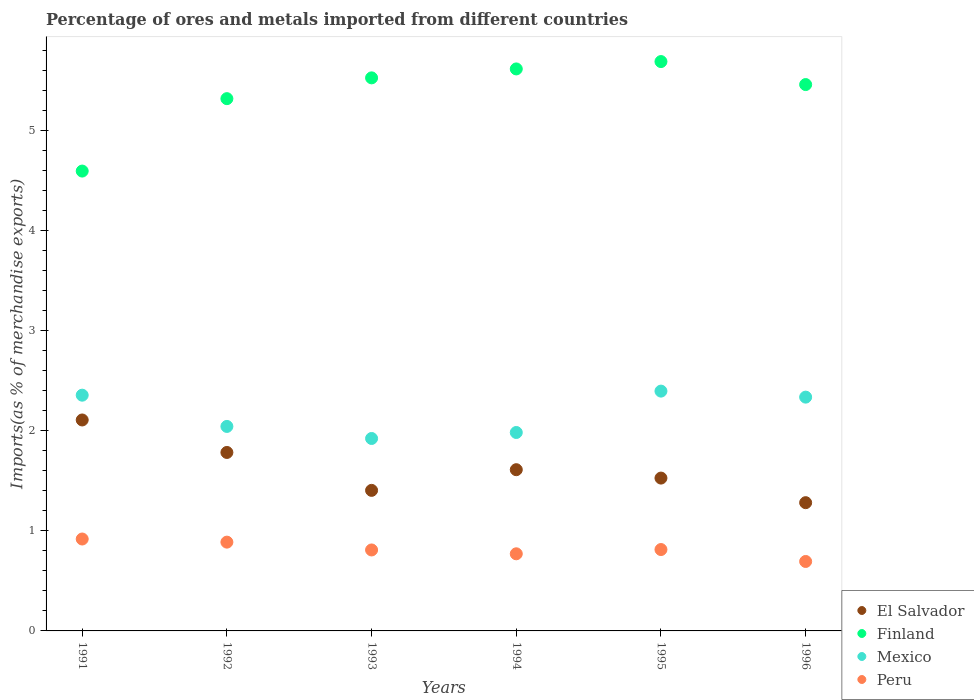How many different coloured dotlines are there?
Offer a terse response. 4. Is the number of dotlines equal to the number of legend labels?
Offer a terse response. Yes. What is the percentage of imports to different countries in Finland in 1991?
Your response must be concise. 4.59. Across all years, what is the maximum percentage of imports to different countries in El Salvador?
Offer a very short reply. 2.11. Across all years, what is the minimum percentage of imports to different countries in Finland?
Provide a succinct answer. 4.59. In which year was the percentage of imports to different countries in El Salvador maximum?
Provide a short and direct response. 1991. In which year was the percentage of imports to different countries in Finland minimum?
Offer a terse response. 1991. What is the total percentage of imports to different countries in Peru in the graph?
Offer a very short reply. 4.89. What is the difference between the percentage of imports to different countries in Mexico in 1992 and that in 1994?
Make the answer very short. 0.06. What is the difference between the percentage of imports to different countries in Peru in 1992 and the percentage of imports to different countries in Mexico in 1996?
Give a very brief answer. -1.45. What is the average percentage of imports to different countries in Mexico per year?
Ensure brevity in your answer.  2.17. In the year 1996, what is the difference between the percentage of imports to different countries in Mexico and percentage of imports to different countries in Peru?
Make the answer very short. 1.64. What is the ratio of the percentage of imports to different countries in Peru in 1993 to that in 1996?
Offer a terse response. 1.17. Is the percentage of imports to different countries in El Salvador in 1993 less than that in 1994?
Provide a succinct answer. Yes. What is the difference between the highest and the second highest percentage of imports to different countries in Mexico?
Make the answer very short. 0.04. What is the difference between the highest and the lowest percentage of imports to different countries in Mexico?
Ensure brevity in your answer.  0.47. Is the sum of the percentage of imports to different countries in El Salvador in 1993 and 1995 greater than the maximum percentage of imports to different countries in Mexico across all years?
Keep it short and to the point. Yes. Is it the case that in every year, the sum of the percentage of imports to different countries in Finland and percentage of imports to different countries in Mexico  is greater than the sum of percentage of imports to different countries in El Salvador and percentage of imports to different countries in Peru?
Give a very brief answer. Yes. Is it the case that in every year, the sum of the percentage of imports to different countries in Finland and percentage of imports to different countries in El Salvador  is greater than the percentage of imports to different countries in Peru?
Provide a succinct answer. Yes. Is the percentage of imports to different countries in Mexico strictly greater than the percentage of imports to different countries in Finland over the years?
Offer a very short reply. No. Is the percentage of imports to different countries in El Salvador strictly less than the percentage of imports to different countries in Peru over the years?
Your answer should be compact. No. How many years are there in the graph?
Provide a succinct answer. 6. Are the values on the major ticks of Y-axis written in scientific E-notation?
Provide a short and direct response. No. Does the graph contain grids?
Provide a succinct answer. No. Where does the legend appear in the graph?
Provide a succinct answer. Bottom right. What is the title of the graph?
Provide a succinct answer. Percentage of ores and metals imported from different countries. Does "Ukraine" appear as one of the legend labels in the graph?
Provide a succinct answer. No. What is the label or title of the Y-axis?
Ensure brevity in your answer.  Imports(as % of merchandise exports). What is the Imports(as % of merchandise exports) of El Salvador in 1991?
Provide a succinct answer. 2.11. What is the Imports(as % of merchandise exports) in Finland in 1991?
Offer a very short reply. 4.59. What is the Imports(as % of merchandise exports) in Mexico in 1991?
Your answer should be compact. 2.36. What is the Imports(as % of merchandise exports) of Peru in 1991?
Give a very brief answer. 0.92. What is the Imports(as % of merchandise exports) of El Salvador in 1992?
Give a very brief answer. 1.78. What is the Imports(as % of merchandise exports) of Finland in 1992?
Keep it short and to the point. 5.32. What is the Imports(as % of merchandise exports) in Mexico in 1992?
Your answer should be very brief. 2.04. What is the Imports(as % of merchandise exports) in Peru in 1992?
Your response must be concise. 0.89. What is the Imports(as % of merchandise exports) in El Salvador in 1993?
Provide a succinct answer. 1.4. What is the Imports(as % of merchandise exports) of Finland in 1993?
Make the answer very short. 5.53. What is the Imports(as % of merchandise exports) of Mexico in 1993?
Your response must be concise. 1.92. What is the Imports(as % of merchandise exports) in Peru in 1993?
Provide a succinct answer. 0.81. What is the Imports(as % of merchandise exports) of El Salvador in 1994?
Ensure brevity in your answer.  1.61. What is the Imports(as % of merchandise exports) in Finland in 1994?
Ensure brevity in your answer.  5.61. What is the Imports(as % of merchandise exports) in Mexico in 1994?
Ensure brevity in your answer.  1.98. What is the Imports(as % of merchandise exports) in Peru in 1994?
Your answer should be very brief. 0.77. What is the Imports(as % of merchandise exports) in El Salvador in 1995?
Your answer should be very brief. 1.53. What is the Imports(as % of merchandise exports) in Finland in 1995?
Offer a very short reply. 5.69. What is the Imports(as % of merchandise exports) of Mexico in 1995?
Provide a short and direct response. 2.4. What is the Imports(as % of merchandise exports) in Peru in 1995?
Ensure brevity in your answer.  0.81. What is the Imports(as % of merchandise exports) in El Salvador in 1996?
Make the answer very short. 1.28. What is the Imports(as % of merchandise exports) of Finland in 1996?
Your answer should be compact. 5.46. What is the Imports(as % of merchandise exports) of Mexico in 1996?
Keep it short and to the point. 2.34. What is the Imports(as % of merchandise exports) of Peru in 1996?
Provide a short and direct response. 0.69. Across all years, what is the maximum Imports(as % of merchandise exports) in El Salvador?
Your answer should be very brief. 2.11. Across all years, what is the maximum Imports(as % of merchandise exports) of Finland?
Provide a short and direct response. 5.69. Across all years, what is the maximum Imports(as % of merchandise exports) of Mexico?
Offer a terse response. 2.4. Across all years, what is the maximum Imports(as % of merchandise exports) of Peru?
Offer a terse response. 0.92. Across all years, what is the minimum Imports(as % of merchandise exports) of El Salvador?
Your answer should be compact. 1.28. Across all years, what is the minimum Imports(as % of merchandise exports) of Finland?
Provide a succinct answer. 4.59. Across all years, what is the minimum Imports(as % of merchandise exports) in Mexico?
Your answer should be compact. 1.92. Across all years, what is the minimum Imports(as % of merchandise exports) of Peru?
Offer a terse response. 0.69. What is the total Imports(as % of merchandise exports) of El Salvador in the graph?
Make the answer very short. 9.71. What is the total Imports(as % of merchandise exports) of Finland in the graph?
Offer a very short reply. 32.2. What is the total Imports(as % of merchandise exports) of Mexico in the graph?
Offer a very short reply. 13.03. What is the total Imports(as % of merchandise exports) in Peru in the graph?
Provide a succinct answer. 4.89. What is the difference between the Imports(as % of merchandise exports) of El Salvador in 1991 and that in 1992?
Offer a terse response. 0.32. What is the difference between the Imports(as % of merchandise exports) in Finland in 1991 and that in 1992?
Keep it short and to the point. -0.72. What is the difference between the Imports(as % of merchandise exports) of Mexico in 1991 and that in 1992?
Offer a terse response. 0.31. What is the difference between the Imports(as % of merchandise exports) of Peru in 1991 and that in 1992?
Provide a short and direct response. 0.03. What is the difference between the Imports(as % of merchandise exports) of El Salvador in 1991 and that in 1993?
Offer a very short reply. 0.7. What is the difference between the Imports(as % of merchandise exports) of Finland in 1991 and that in 1993?
Offer a very short reply. -0.93. What is the difference between the Imports(as % of merchandise exports) in Mexico in 1991 and that in 1993?
Give a very brief answer. 0.43. What is the difference between the Imports(as % of merchandise exports) of Peru in 1991 and that in 1993?
Make the answer very short. 0.11. What is the difference between the Imports(as % of merchandise exports) of El Salvador in 1991 and that in 1994?
Your response must be concise. 0.5. What is the difference between the Imports(as % of merchandise exports) of Finland in 1991 and that in 1994?
Give a very brief answer. -1.02. What is the difference between the Imports(as % of merchandise exports) of Mexico in 1991 and that in 1994?
Ensure brevity in your answer.  0.37. What is the difference between the Imports(as % of merchandise exports) of Peru in 1991 and that in 1994?
Offer a very short reply. 0.15. What is the difference between the Imports(as % of merchandise exports) in El Salvador in 1991 and that in 1995?
Your answer should be very brief. 0.58. What is the difference between the Imports(as % of merchandise exports) of Finland in 1991 and that in 1995?
Your answer should be compact. -1.09. What is the difference between the Imports(as % of merchandise exports) in Mexico in 1991 and that in 1995?
Provide a succinct answer. -0.04. What is the difference between the Imports(as % of merchandise exports) in Peru in 1991 and that in 1995?
Give a very brief answer. 0.11. What is the difference between the Imports(as % of merchandise exports) of El Salvador in 1991 and that in 1996?
Make the answer very short. 0.83. What is the difference between the Imports(as % of merchandise exports) of Finland in 1991 and that in 1996?
Provide a short and direct response. -0.86. What is the difference between the Imports(as % of merchandise exports) of Mexico in 1991 and that in 1996?
Your answer should be compact. 0.02. What is the difference between the Imports(as % of merchandise exports) in Peru in 1991 and that in 1996?
Provide a short and direct response. 0.22. What is the difference between the Imports(as % of merchandise exports) in El Salvador in 1992 and that in 1993?
Make the answer very short. 0.38. What is the difference between the Imports(as % of merchandise exports) of Finland in 1992 and that in 1993?
Your answer should be compact. -0.21. What is the difference between the Imports(as % of merchandise exports) in Mexico in 1992 and that in 1993?
Your answer should be very brief. 0.12. What is the difference between the Imports(as % of merchandise exports) of Peru in 1992 and that in 1993?
Provide a succinct answer. 0.08. What is the difference between the Imports(as % of merchandise exports) in El Salvador in 1992 and that in 1994?
Offer a very short reply. 0.17. What is the difference between the Imports(as % of merchandise exports) in Finland in 1992 and that in 1994?
Ensure brevity in your answer.  -0.3. What is the difference between the Imports(as % of merchandise exports) in Mexico in 1992 and that in 1994?
Your answer should be very brief. 0.06. What is the difference between the Imports(as % of merchandise exports) of Peru in 1992 and that in 1994?
Provide a succinct answer. 0.12. What is the difference between the Imports(as % of merchandise exports) of El Salvador in 1992 and that in 1995?
Give a very brief answer. 0.26. What is the difference between the Imports(as % of merchandise exports) of Finland in 1992 and that in 1995?
Your answer should be very brief. -0.37. What is the difference between the Imports(as % of merchandise exports) of Mexico in 1992 and that in 1995?
Your response must be concise. -0.35. What is the difference between the Imports(as % of merchandise exports) of Peru in 1992 and that in 1995?
Provide a succinct answer. 0.07. What is the difference between the Imports(as % of merchandise exports) of El Salvador in 1992 and that in 1996?
Keep it short and to the point. 0.5. What is the difference between the Imports(as % of merchandise exports) in Finland in 1992 and that in 1996?
Your response must be concise. -0.14. What is the difference between the Imports(as % of merchandise exports) in Mexico in 1992 and that in 1996?
Provide a succinct answer. -0.29. What is the difference between the Imports(as % of merchandise exports) in Peru in 1992 and that in 1996?
Keep it short and to the point. 0.19. What is the difference between the Imports(as % of merchandise exports) in El Salvador in 1993 and that in 1994?
Offer a very short reply. -0.21. What is the difference between the Imports(as % of merchandise exports) of Finland in 1993 and that in 1994?
Ensure brevity in your answer.  -0.09. What is the difference between the Imports(as % of merchandise exports) in Mexico in 1993 and that in 1994?
Your answer should be compact. -0.06. What is the difference between the Imports(as % of merchandise exports) of Peru in 1993 and that in 1994?
Provide a succinct answer. 0.04. What is the difference between the Imports(as % of merchandise exports) of El Salvador in 1993 and that in 1995?
Offer a terse response. -0.12. What is the difference between the Imports(as % of merchandise exports) of Finland in 1993 and that in 1995?
Ensure brevity in your answer.  -0.16. What is the difference between the Imports(as % of merchandise exports) in Mexico in 1993 and that in 1995?
Provide a succinct answer. -0.47. What is the difference between the Imports(as % of merchandise exports) of Peru in 1993 and that in 1995?
Your response must be concise. -0. What is the difference between the Imports(as % of merchandise exports) in El Salvador in 1993 and that in 1996?
Give a very brief answer. 0.12. What is the difference between the Imports(as % of merchandise exports) in Finland in 1993 and that in 1996?
Ensure brevity in your answer.  0.07. What is the difference between the Imports(as % of merchandise exports) of Mexico in 1993 and that in 1996?
Make the answer very short. -0.41. What is the difference between the Imports(as % of merchandise exports) in Peru in 1993 and that in 1996?
Offer a very short reply. 0.12. What is the difference between the Imports(as % of merchandise exports) in El Salvador in 1994 and that in 1995?
Make the answer very short. 0.08. What is the difference between the Imports(as % of merchandise exports) of Finland in 1994 and that in 1995?
Offer a very short reply. -0.07. What is the difference between the Imports(as % of merchandise exports) in Mexico in 1994 and that in 1995?
Offer a very short reply. -0.41. What is the difference between the Imports(as % of merchandise exports) in Peru in 1994 and that in 1995?
Offer a very short reply. -0.04. What is the difference between the Imports(as % of merchandise exports) of El Salvador in 1994 and that in 1996?
Your answer should be very brief. 0.33. What is the difference between the Imports(as % of merchandise exports) of Finland in 1994 and that in 1996?
Your response must be concise. 0.16. What is the difference between the Imports(as % of merchandise exports) of Mexico in 1994 and that in 1996?
Keep it short and to the point. -0.35. What is the difference between the Imports(as % of merchandise exports) of Peru in 1994 and that in 1996?
Provide a succinct answer. 0.08. What is the difference between the Imports(as % of merchandise exports) of El Salvador in 1995 and that in 1996?
Your response must be concise. 0.25. What is the difference between the Imports(as % of merchandise exports) in Finland in 1995 and that in 1996?
Provide a succinct answer. 0.23. What is the difference between the Imports(as % of merchandise exports) in Mexico in 1995 and that in 1996?
Provide a succinct answer. 0.06. What is the difference between the Imports(as % of merchandise exports) in Peru in 1995 and that in 1996?
Provide a short and direct response. 0.12. What is the difference between the Imports(as % of merchandise exports) in El Salvador in 1991 and the Imports(as % of merchandise exports) in Finland in 1992?
Your response must be concise. -3.21. What is the difference between the Imports(as % of merchandise exports) in El Salvador in 1991 and the Imports(as % of merchandise exports) in Mexico in 1992?
Give a very brief answer. 0.06. What is the difference between the Imports(as % of merchandise exports) in El Salvador in 1991 and the Imports(as % of merchandise exports) in Peru in 1992?
Give a very brief answer. 1.22. What is the difference between the Imports(as % of merchandise exports) in Finland in 1991 and the Imports(as % of merchandise exports) in Mexico in 1992?
Ensure brevity in your answer.  2.55. What is the difference between the Imports(as % of merchandise exports) in Finland in 1991 and the Imports(as % of merchandise exports) in Peru in 1992?
Your answer should be compact. 3.71. What is the difference between the Imports(as % of merchandise exports) of Mexico in 1991 and the Imports(as % of merchandise exports) of Peru in 1992?
Your response must be concise. 1.47. What is the difference between the Imports(as % of merchandise exports) in El Salvador in 1991 and the Imports(as % of merchandise exports) in Finland in 1993?
Ensure brevity in your answer.  -3.42. What is the difference between the Imports(as % of merchandise exports) of El Salvador in 1991 and the Imports(as % of merchandise exports) of Mexico in 1993?
Offer a terse response. 0.18. What is the difference between the Imports(as % of merchandise exports) of El Salvador in 1991 and the Imports(as % of merchandise exports) of Peru in 1993?
Provide a succinct answer. 1.3. What is the difference between the Imports(as % of merchandise exports) of Finland in 1991 and the Imports(as % of merchandise exports) of Mexico in 1993?
Make the answer very short. 2.67. What is the difference between the Imports(as % of merchandise exports) of Finland in 1991 and the Imports(as % of merchandise exports) of Peru in 1993?
Provide a short and direct response. 3.79. What is the difference between the Imports(as % of merchandise exports) of Mexico in 1991 and the Imports(as % of merchandise exports) of Peru in 1993?
Ensure brevity in your answer.  1.55. What is the difference between the Imports(as % of merchandise exports) in El Salvador in 1991 and the Imports(as % of merchandise exports) in Finland in 1994?
Your answer should be compact. -3.51. What is the difference between the Imports(as % of merchandise exports) in El Salvador in 1991 and the Imports(as % of merchandise exports) in Mexico in 1994?
Your response must be concise. 0.13. What is the difference between the Imports(as % of merchandise exports) of El Salvador in 1991 and the Imports(as % of merchandise exports) of Peru in 1994?
Your response must be concise. 1.34. What is the difference between the Imports(as % of merchandise exports) of Finland in 1991 and the Imports(as % of merchandise exports) of Mexico in 1994?
Give a very brief answer. 2.61. What is the difference between the Imports(as % of merchandise exports) of Finland in 1991 and the Imports(as % of merchandise exports) of Peru in 1994?
Provide a succinct answer. 3.82. What is the difference between the Imports(as % of merchandise exports) of Mexico in 1991 and the Imports(as % of merchandise exports) of Peru in 1994?
Provide a succinct answer. 1.58. What is the difference between the Imports(as % of merchandise exports) of El Salvador in 1991 and the Imports(as % of merchandise exports) of Finland in 1995?
Offer a very short reply. -3.58. What is the difference between the Imports(as % of merchandise exports) in El Salvador in 1991 and the Imports(as % of merchandise exports) in Mexico in 1995?
Offer a terse response. -0.29. What is the difference between the Imports(as % of merchandise exports) in El Salvador in 1991 and the Imports(as % of merchandise exports) in Peru in 1995?
Give a very brief answer. 1.29. What is the difference between the Imports(as % of merchandise exports) in Finland in 1991 and the Imports(as % of merchandise exports) in Mexico in 1995?
Provide a short and direct response. 2.2. What is the difference between the Imports(as % of merchandise exports) in Finland in 1991 and the Imports(as % of merchandise exports) in Peru in 1995?
Offer a terse response. 3.78. What is the difference between the Imports(as % of merchandise exports) in Mexico in 1991 and the Imports(as % of merchandise exports) in Peru in 1995?
Offer a terse response. 1.54. What is the difference between the Imports(as % of merchandise exports) of El Salvador in 1991 and the Imports(as % of merchandise exports) of Finland in 1996?
Make the answer very short. -3.35. What is the difference between the Imports(as % of merchandise exports) in El Salvador in 1991 and the Imports(as % of merchandise exports) in Mexico in 1996?
Make the answer very short. -0.23. What is the difference between the Imports(as % of merchandise exports) in El Salvador in 1991 and the Imports(as % of merchandise exports) in Peru in 1996?
Provide a short and direct response. 1.41. What is the difference between the Imports(as % of merchandise exports) of Finland in 1991 and the Imports(as % of merchandise exports) of Mexico in 1996?
Your response must be concise. 2.26. What is the difference between the Imports(as % of merchandise exports) in Finland in 1991 and the Imports(as % of merchandise exports) in Peru in 1996?
Provide a succinct answer. 3.9. What is the difference between the Imports(as % of merchandise exports) of Mexico in 1991 and the Imports(as % of merchandise exports) of Peru in 1996?
Your answer should be compact. 1.66. What is the difference between the Imports(as % of merchandise exports) in El Salvador in 1992 and the Imports(as % of merchandise exports) in Finland in 1993?
Provide a short and direct response. -3.74. What is the difference between the Imports(as % of merchandise exports) in El Salvador in 1992 and the Imports(as % of merchandise exports) in Mexico in 1993?
Offer a terse response. -0.14. What is the difference between the Imports(as % of merchandise exports) of El Salvador in 1992 and the Imports(as % of merchandise exports) of Peru in 1993?
Give a very brief answer. 0.97. What is the difference between the Imports(as % of merchandise exports) in Finland in 1992 and the Imports(as % of merchandise exports) in Mexico in 1993?
Make the answer very short. 3.4. What is the difference between the Imports(as % of merchandise exports) of Finland in 1992 and the Imports(as % of merchandise exports) of Peru in 1993?
Make the answer very short. 4.51. What is the difference between the Imports(as % of merchandise exports) of Mexico in 1992 and the Imports(as % of merchandise exports) of Peru in 1993?
Offer a terse response. 1.23. What is the difference between the Imports(as % of merchandise exports) of El Salvador in 1992 and the Imports(as % of merchandise exports) of Finland in 1994?
Offer a very short reply. -3.83. What is the difference between the Imports(as % of merchandise exports) of El Salvador in 1992 and the Imports(as % of merchandise exports) of Mexico in 1994?
Your answer should be very brief. -0.2. What is the difference between the Imports(as % of merchandise exports) in El Salvador in 1992 and the Imports(as % of merchandise exports) in Peru in 1994?
Your answer should be very brief. 1.01. What is the difference between the Imports(as % of merchandise exports) in Finland in 1992 and the Imports(as % of merchandise exports) in Mexico in 1994?
Your answer should be compact. 3.34. What is the difference between the Imports(as % of merchandise exports) in Finland in 1992 and the Imports(as % of merchandise exports) in Peru in 1994?
Keep it short and to the point. 4.55. What is the difference between the Imports(as % of merchandise exports) of Mexico in 1992 and the Imports(as % of merchandise exports) of Peru in 1994?
Provide a short and direct response. 1.27. What is the difference between the Imports(as % of merchandise exports) of El Salvador in 1992 and the Imports(as % of merchandise exports) of Finland in 1995?
Give a very brief answer. -3.9. What is the difference between the Imports(as % of merchandise exports) of El Salvador in 1992 and the Imports(as % of merchandise exports) of Mexico in 1995?
Keep it short and to the point. -0.61. What is the difference between the Imports(as % of merchandise exports) in El Salvador in 1992 and the Imports(as % of merchandise exports) in Peru in 1995?
Your answer should be compact. 0.97. What is the difference between the Imports(as % of merchandise exports) of Finland in 1992 and the Imports(as % of merchandise exports) of Mexico in 1995?
Your answer should be very brief. 2.92. What is the difference between the Imports(as % of merchandise exports) in Finland in 1992 and the Imports(as % of merchandise exports) in Peru in 1995?
Ensure brevity in your answer.  4.5. What is the difference between the Imports(as % of merchandise exports) of Mexico in 1992 and the Imports(as % of merchandise exports) of Peru in 1995?
Provide a succinct answer. 1.23. What is the difference between the Imports(as % of merchandise exports) in El Salvador in 1992 and the Imports(as % of merchandise exports) in Finland in 1996?
Offer a terse response. -3.68. What is the difference between the Imports(as % of merchandise exports) of El Salvador in 1992 and the Imports(as % of merchandise exports) of Mexico in 1996?
Offer a very short reply. -0.55. What is the difference between the Imports(as % of merchandise exports) in El Salvador in 1992 and the Imports(as % of merchandise exports) in Peru in 1996?
Your response must be concise. 1.09. What is the difference between the Imports(as % of merchandise exports) in Finland in 1992 and the Imports(as % of merchandise exports) in Mexico in 1996?
Provide a succinct answer. 2.98. What is the difference between the Imports(as % of merchandise exports) in Finland in 1992 and the Imports(as % of merchandise exports) in Peru in 1996?
Provide a short and direct response. 4.62. What is the difference between the Imports(as % of merchandise exports) of Mexico in 1992 and the Imports(as % of merchandise exports) of Peru in 1996?
Offer a terse response. 1.35. What is the difference between the Imports(as % of merchandise exports) of El Salvador in 1993 and the Imports(as % of merchandise exports) of Finland in 1994?
Your answer should be very brief. -4.21. What is the difference between the Imports(as % of merchandise exports) of El Salvador in 1993 and the Imports(as % of merchandise exports) of Mexico in 1994?
Your answer should be very brief. -0.58. What is the difference between the Imports(as % of merchandise exports) in El Salvador in 1993 and the Imports(as % of merchandise exports) in Peru in 1994?
Your answer should be very brief. 0.63. What is the difference between the Imports(as % of merchandise exports) in Finland in 1993 and the Imports(as % of merchandise exports) in Mexico in 1994?
Give a very brief answer. 3.54. What is the difference between the Imports(as % of merchandise exports) in Finland in 1993 and the Imports(as % of merchandise exports) in Peru in 1994?
Your answer should be very brief. 4.75. What is the difference between the Imports(as % of merchandise exports) of Mexico in 1993 and the Imports(as % of merchandise exports) of Peru in 1994?
Provide a succinct answer. 1.15. What is the difference between the Imports(as % of merchandise exports) of El Salvador in 1993 and the Imports(as % of merchandise exports) of Finland in 1995?
Make the answer very short. -4.28. What is the difference between the Imports(as % of merchandise exports) of El Salvador in 1993 and the Imports(as % of merchandise exports) of Mexico in 1995?
Provide a short and direct response. -0.99. What is the difference between the Imports(as % of merchandise exports) in El Salvador in 1993 and the Imports(as % of merchandise exports) in Peru in 1995?
Give a very brief answer. 0.59. What is the difference between the Imports(as % of merchandise exports) of Finland in 1993 and the Imports(as % of merchandise exports) of Mexico in 1995?
Offer a terse response. 3.13. What is the difference between the Imports(as % of merchandise exports) in Finland in 1993 and the Imports(as % of merchandise exports) in Peru in 1995?
Make the answer very short. 4.71. What is the difference between the Imports(as % of merchandise exports) of Mexico in 1993 and the Imports(as % of merchandise exports) of Peru in 1995?
Provide a short and direct response. 1.11. What is the difference between the Imports(as % of merchandise exports) in El Salvador in 1993 and the Imports(as % of merchandise exports) in Finland in 1996?
Make the answer very short. -4.05. What is the difference between the Imports(as % of merchandise exports) of El Salvador in 1993 and the Imports(as % of merchandise exports) of Mexico in 1996?
Your answer should be compact. -0.93. What is the difference between the Imports(as % of merchandise exports) of El Salvador in 1993 and the Imports(as % of merchandise exports) of Peru in 1996?
Your answer should be compact. 0.71. What is the difference between the Imports(as % of merchandise exports) in Finland in 1993 and the Imports(as % of merchandise exports) in Mexico in 1996?
Your response must be concise. 3.19. What is the difference between the Imports(as % of merchandise exports) of Finland in 1993 and the Imports(as % of merchandise exports) of Peru in 1996?
Provide a short and direct response. 4.83. What is the difference between the Imports(as % of merchandise exports) of Mexico in 1993 and the Imports(as % of merchandise exports) of Peru in 1996?
Provide a short and direct response. 1.23. What is the difference between the Imports(as % of merchandise exports) in El Salvador in 1994 and the Imports(as % of merchandise exports) in Finland in 1995?
Keep it short and to the point. -4.08. What is the difference between the Imports(as % of merchandise exports) of El Salvador in 1994 and the Imports(as % of merchandise exports) of Mexico in 1995?
Give a very brief answer. -0.79. What is the difference between the Imports(as % of merchandise exports) in El Salvador in 1994 and the Imports(as % of merchandise exports) in Peru in 1995?
Your response must be concise. 0.8. What is the difference between the Imports(as % of merchandise exports) in Finland in 1994 and the Imports(as % of merchandise exports) in Mexico in 1995?
Offer a terse response. 3.22. What is the difference between the Imports(as % of merchandise exports) of Finland in 1994 and the Imports(as % of merchandise exports) of Peru in 1995?
Offer a terse response. 4.8. What is the difference between the Imports(as % of merchandise exports) in Mexico in 1994 and the Imports(as % of merchandise exports) in Peru in 1995?
Ensure brevity in your answer.  1.17. What is the difference between the Imports(as % of merchandise exports) in El Salvador in 1994 and the Imports(as % of merchandise exports) in Finland in 1996?
Give a very brief answer. -3.85. What is the difference between the Imports(as % of merchandise exports) of El Salvador in 1994 and the Imports(as % of merchandise exports) of Mexico in 1996?
Your answer should be very brief. -0.72. What is the difference between the Imports(as % of merchandise exports) in El Salvador in 1994 and the Imports(as % of merchandise exports) in Peru in 1996?
Offer a terse response. 0.92. What is the difference between the Imports(as % of merchandise exports) of Finland in 1994 and the Imports(as % of merchandise exports) of Mexico in 1996?
Ensure brevity in your answer.  3.28. What is the difference between the Imports(as % of merchandise exports) of Finland in 1994 and the Imports(as % of merchandise exports) of Peru in 1996?
Your response must be concise. 4.92. What is the difference between the Imports(as % of merchandise exports) of Mexico in 1994 and the Imports(as % of merchandise exports) of Peru in 1996?
Give a very brief answer. 1.29. What is the difference between the Imports(as % of merchandise exports) of El Salvador in 1995 and the Imports(as % of merchandise exports) of Finland in 1996?
Make the answer very short. -3.93. What is the difference between the Imports(as % of merchandise exports) in El Salvador in 1995 and the Imports(as % of merchandise exports) in Mexico in 1996?
Make the answer very short. -0.81. What is the difference between the Imports(as % of merchandise exports) of El Salvador in 1995 and the Imports(as % of merchandise exports) of Peru in 1996?
Provide a short and direct response. 0.83. What is the difference between the Imports(as % of merchandise exports) of Finland in 1995 and the Imports(as % of merchandise exports) of Mexico in 1996?
Ensure brevity in your answer.  3.35. What is the difference between the Imports(as % of merchandise exports) of Finland in 1995 and the Imports(as % of merchandise exports) of Peru in 1996?
Your response must be concise. 4.99. What is the difference between the Imports(as % of merchandise exports) of Mexico in 1995 and the Imports(as % of merchandise exports) of Peru in 1996?
Make the answer very short. 1.7. What is the average Imports(as % of merchandise exports) in El Salvador per year?
Offer a very short reply. 1.62. What is the average Imports(as % of merchandise exports) of Finland per year?
Make the answer very short. 5.37. What is the average Imports(as % of merchandise exports) of Mexico per year?
Offer a terse response. 2.17. What is the average Imports(as % of merchandise exports) of Peru per year?
Keep it short and to the point. 0.82. In the year 1991, what is the difference between the Imports(as % of merchandise exports) of El Salvador and Imports(as % of merchandise exports) of Finland?
Your answer should be very brief. -2.49. In the year 1991, what is the difference between the Imports(as % of merchandise exports) of El Salvador and Imports(as % of merchandise exports) of Mexico?
Offer a very short reply. -0.25. In the year 1991, what is the difference between the Imports(as % of merchandise exports) of El Salvador and Imports(as % of merchandise exports) of Peru?
Make the answer very short. 1.19. In the year 1991, what is the difference between the Imports(as % of merchandise exports) of Finland and Imports(as % of merchandise exports) of Mexico?
Ensure brevity in your answer.  2.24. In the year 1991, what is the difference between the Imports(as % of merchandise exports) of Finland and Imports(as % of merchandise exports) of Peru?
Provide a succinct answer. 3.68. In the year 1991, what is the difference between the Imports(as % of merchandise exports) in Mexico and Imports(as % of merchandise exports) in Peru?
Give a very brief answer. 1.44. In the year 1992, what is the difference between the Imports(as % of merchandise exports) of El Salvador and Imports(as % of merchandise exports) of Finland?
Offer a terse response. -3.53. In the year 1992, what is the difference between the Imports(as % of merchandise exports) in El Salvador and Imports(as % of merchandise exports) in Mexico?
Keep it short and to the point. -0.26. In the year 1992, what is the difference between the Imports(as % of merchandise exports) of El Salvador and Imports(as % of merchandise exports) of Peru?
Provide a short and direct response. 0.9. In the year 1992, what is the difference between the Imports(as % of merchandise exports) of Finland and Imports(as % of merchandise exports) of Mexico?
Your answer should be very brief. 3.27. In the year 1992, what is the difference between the Imports(as % of merchandise exports) in Finland and Imports(as % of merchandise exports) in Peru?
Offer a very short reply. 4.43. In the year 1992, what is the difference between the Imports(as % of merchandise exports) of Mexico and Imports(as % of merchandise exports) of Peru?
Ensure brevity in your answer.  1.16. In the year 1993, what is the difference between the Imports(as % of merchandise exports) in El Salvador and Imports(as % of merchandise exports) in Finland?
Make the answer very short. -4.12. In the year 1993, what is the difference between the Imports(as % of merchandise exports) of El Salvador and Imports(as % of merchandise exports) of Mexico?
Ensure brevity in your answer.  -0.52. In the year 1993, what is the difference between the Imports(as % of merchandise exports) of El Salvador and Imports(as % of merchandise exports) of Peru?
Ensure brevity in your answer.  0.6. In the year 1993, what is the difference between the Imports(as % of merchandise exports) in Finland and Imports(as % of merchandise exports) in Mexico?
Make the answer very short. 3.6. In the year 1993, what is the difference between the Imports(as % of merchandise exports) of Finland and Imports(as % of merchandise exports) of Peru?
Provide a short and direct response. 4.72. In the year 1993, what is the difference between the Imports(as % of merchandise exports) of Mexico and Imports(as % of merchandise exports) of Peru?
Provide a succinct answer. 1.11. In the year 1994, what is the difference between the Imports(as % of merchandise exports) of El Salvador and Imports(as % of merchandise exports) of Finland?
Ensure brevity in your answer.  -4. In the year 1994, what is the difference between the Imports(as % of merchandise exports) of El Salvador and Imports(as % of merchandise exports) of Mexico?
Give a very brief answer. -0.37. In the year 1994, what is the difference between the Imports(as % of merchandise exports) in El Salvador and Imports(as % of merchandise exports) in Peru?
Provide a short and direct response. 0.84. In the year 1994, what is the difference between the Imports(as % of merchandise exports) in Finland and Imports(as % of merchandise exports) in Mexico?
Your answer should be very brief. 3.63. In the year 1994, what is the difference between the Imports(as % of merchandise exports) in Finland and Imports(as % of merchandise exports) in Peru?
Your answer should be compact. 4.84. In the year 1994, what is the difference between the Imports(as % of merchandise exports) in Mexico and Imports(as % of merchandise exports) in Peru?
Give a very brief answer. 1.21. In the year 1995, what is the difference between the Imports(as % of merchandise exports) of El Salvador and Imports(as % of merchandise exports) of Finland?
Ensure brevity in your answer.  -4.16. In the year 1995, what is the difference between the Imports(as % of merchandise exports) of El Salvador and Imports(as % of merchandise exports) of Mexico?
Your answer should be compact. -0.87. In the year 1995, what is the difference between the Imports(as % of merchandise exports) in El Salvador and Imports(as % of merchandise exports) in Peru?
Make the answer very short. 0.71. In the year 1995, what is the difference between the Imports(as % of merchandise exports) of Finland and Imports(as % of merchandise exports) of Mexico?
Make the answer very short. 3.29. In the year 1995, what is the difference between the Imports(as % of merchandise exports) in Finland and Imports(as % of merchandise exports) in Peru?
Offer a very short reply. 4.87. In the year 1995, what is the difference between the Imports(as % of merchandise exports) in Mexico and Imports(as % of merchandise exports) in Peru?
Provide a short and direct response. 1.58. In the year 1996, what is the difference between the Imports(as % of merchandise exports) in El Salvador and Imports(as % of merchandise exports) in Finland?
Make the answer very short. -4.18. In the year 1996, what is the difference between the Imports(as % of merchandise exports) in El Salvador and Imports(as % of merchandise exports) in Mexico?
Provide a short and direct response. -1.05. In the year 1996, what is the difference between the Imports(as % of merchandise exports) in El Salvador and Imports(as % of merchandise exports) in Peru?
Offer a very short reply. 0.59. In the year 1996, what is the difference between the Imports(as % of merchandise exports) of Finland and Imports(as % of merchandise exports) of Mexico?
Provide a succinct answer. 3.12. In the year 1996, what is the difference between the Imports(as % of merchandise exports) in Finland and Imports(as % of merchandise exports) in Peru?
Ensure brevity in your answer.  4.76. In the year 1996, what is the difference between the Imports(as % of merchandise exports) of Mexico and Imports(as % of merchandise exports) of Peru?
Ensure brevity in your answer.  1.64. What is the ratio of the Imports(as % of merchandise exports) of El Salvador in 1991 to that in 1992?
Offer a terse response. 1.18. What is the ratio of the Imports(as % of merchandise exports) of Finland in 1991 to that in 1992?
Give a very brief answer. 0.86. What is the ratio of the Imports(as % of merchandise exports) in Mexico in 1991 to that in 1992?
Your answer should be very brief. 1.15. What is the ratio of the Imports(as % of merchandise exports) in Peru in 1991 to that in 1992?
Ensure brevity in your answer.  1.04. What is the ratio of the Imports(as % of merchandise exports) in El Salvador in 1991 to that in 1993?
Ensure brevity in your answer.  1.5. What is the ratio of the Imports(as % of merchandise exports) of Finland in 1991 to that in 1993?
Your answer should be very brief. 0.83. What is the ratio of the Imports(as % of merchandise exports) of Mexico in 1991 to that in 1993?
Keep it short and to the point. 1.23. What is the ratio of the Imports(as % of merchandise exports) in Peru in 1991 to that in 1993?
Provide a short and direct response. 1.14. What is the ratio of the Imports(as % of merchandise exports) in El Salvador in 1991 to that in 1994?
Your response must be concise. 1.31. What is the ratio of the Imports(as % of merchandise exports) of Finland in 1991 to that in 1994?
Provide a short and direct response. 0.82. What is the ratio of the Imports(as % of merchandise exports) of Mexico in 1991 to that in 1994?
Your response must be concise. 1.19. What is the ratio of the Imports(as % of merchandise exports) in Peru in 1991 to that in 1994?
Offer a very short reply. 1.19. What is the ratio of the Imports(as % of merchandise exports) in El Salvador in 1991 to that in 1995?
Make the answer very short. 1.38. What is the ratio of the Imports(as % of merchandise exports) of Finland in 1991 to that in 1995?
Ensure brevity in your answer.  0.81. What is the ratio of the Imports(as % of merchandise exports) in Peru in 1991 to that in 1995?
Provide a short and direct response. 1.13. What is the ratio of the Imports(as % of merchandise exports) in El Salvador in 1991 to that in 1996?
Provide a succinct answer. 1.64. What is the ratio of the Imports(as % of merchandise exports) of Finland in 1991 to that in 1996?
Give a very brief answer. 0.84. What is the ratio of the Imports(as % of merchandise exports) of Mexico in 1991 to that in 1996?
Your answer should be very brief. 1.01. What is the ratio of the Imports(as % of merchandise exports) in Peru in 1991 to that in 1996?
Your response must be concise. 1.32. What is the ratio of the Imports(as % of merchandise exports) in El Salvador in 1992 to that in 1993?
Offer a terse response. 1.27. What is the ratio of the Imports(as % of merchandise exports) of Finland in 1992 to that in 1993?
Give a very brief answer. 0.96. What is the ratio of the Imports(as % of merchandise exports) of Mexico in 1992 to that in 1993?
Provide a short and direct response. 1.06. What is the ratio of the Imports(as % of merchandise exports) in Peru in 1992 to that in 1993?
Give a very brief answer. 1.1. What is the ratio of the Imports(as % of merchandise exports) in El Salvador in 1992 to that in 1994?
Give a very brief answer. 1.11. What is the ratio of the Imports(as % of merchandise exports) of Finland in 1992 to that in 1994?
Offer a terse response. 0.95. What is the ratio of the Imports(as % of merchandise exports) in Mexico in 1992 to that in 1994?
Offer a terse response. 1.03. What is the ratio of the Imports(as % of merchandise exports) in Peru in 1992 to that in 1994?
Make the answer very short. 1.15. What is the ratio of the Imports(as % of merchandise exports) in El Salvador in 1992 to that in 1995?
Offer a terse response. 1.17. What is the ratio of the Imports(as % of merchandise exports) in Finland in 1992 to that in 1995?
Provide a short and direct response. 0.93. What is the ratio of the Imports(as % of merchandise exports) in Mexico in 1992 to that in 1995?
Offer a very short reply. 0.85. What is the ratio of the Imports(as % of merchandise exports) of Peru in 1992 to that in 1995?
Ensure brevity in your answer.  1.09. What is the ratio of the Imports(as % of merchandise exports) in El Salvador in 1992 to that in 1996?
Offer a terse response. 1.39. What is the ratio of the Imports(as % of merchandise exports) of Finland in 1992 to that in 1996?
Keep it short and to the point. 0.97. What is the ratio of the Imports(as % of merchandise exports) in Mexico in 1992 to that in 1996?
Offer a terse response. 0.87. What is the ratio of the Imports(as % of merchandise exports) of Peru in 1992 to that in 1996?
Provide a succinct answer. 1.28. What is the ratio of the Imports(as % of merchandise exports) of El Salvador in 1993 to that in 1994?
Keep it short and to the point. 0.87. What is the ratio of the Imports(as % of merchandise exports) in Finland in 1993 to that in 1994?
Keep it short and to the point. 0.98. What is the ratio of the Imports(as % of merchandise exports) in Mexico in 1993 to that in 1994?
Make the answer very short. 0.97. What is the ratio of the Imports(as % of merchandise exports) of Peru in 1993 to that in 1994?
Offer a terse response. 1.05. What is the ratio of the Imports(as % of merchandise exports) in El Salvador in 1993 to that in 1995?
Give a very brief answer. 0.92. What is the ratio of the Imports(as % of merchandise exports) in Finland in 1993 to that in 1995?
Make the answer very short. 0.97. What is the ratio of the Imports(as % of merchandise exports) of Mexico in 1993 to that in 1995?
Give a very brief answer. 0.8. What is the ratio of the Imports(as % of merchandise exports) of Peru in 1993 to that in 1995?
Ensure brevity in your answer.  0.99. What is the ratio of the Imports(as % of merchandise exports) of El Salvador in 1993 to that in 1996?
Provide a succinct answer. 1.1. What is the ratio of the Imports(as % of merchandise exports) in Finland in 1993 to that in 1996?
Your response must be concise. 1.01. What is the ratio of the Imports(as % of merchandise exports) in Mexico in 1993 to that in 1996?
Provide a short and direct response. 0.82. What is the ratio of the Imports(as % of merchandise exports) of Peru in 1993 to that in 1996?
Keep it short and to the point. 1.17. What is the ratio of the Imports(as % of merchandise exports) in El Salvador in 1994 to that in 1995?
Keep it short and to the point. 1.05. What is the ratio of the Imports(as % of merchandise exports) of Finland in 1994 to that in 1995?
Your answer should be compact. 0.99. What is the ratio of the Imports(as % of merchandise exports) in Mexico in 1994 to that in 1995?
Provide a short and direct response. 0.83. What is the ratio of the Imports(as % of merchandise exports) in Peru in 1994 to that in 1995?
Your response must be concise. 0.95. What is the ratio of the Imports(as % of merchandise exports) of El Salvador in 1994 to that in 1996?
Your response must be concise. 1.26. What is the ratio of the Imports(as % of merchandise exports) in Finland in 1994 to that in 1996?
Keep it short and to the point. 1.03. What is the ratio of the Imports(as % of merchandise exports) in Mexico in 1994 to that in 1996?
Your answer should be very brief. 0.85. What is the ratio of the Imports(as % of merchandise exports) of Peru in 1994 to that in 1996?
Provide a succinct answer. 1.11. What is the ratio of the Imports(as % of merchandise exports) of El Salvador in 1995 to that in 1996?
Offer a very short reply. 1.19. What is the ratio of the Imports(as % of merchandise exports) in Finland in 1995 to that in 1996?
Make the answer very short. 1.04. What is the ratio of the Imports(as % of merchandise exports) of Mexico in 1995 to that in 1996?
Your response must be concise. 1.03. What is the ratio of the Imports(as % of merchandise exports) of Peru in 1995 to that in 1996?
Provide a succinct answer. 1.17. What is the difference between the highest and the second highest Imports(as % of merchandise exports) of El Salvador?
Make the answer very short. 0.32. What is the difference between the highest and the second highest Imports(as % of merchandise exports) in Finland?
Give a very brief answer. 0.07. What is the difference between the highest and the second highest Imports(as % of merchandise exports) in Mexico?
Your answer should be compact. 0.04. What is the difference between the highest and the second highest Imports(as % of merchandise exports) of Peru?
Provide a succinct answer. 0.03. What is the difference between the highest and the lowest Imports(as % of merchandise exports) in El Salvador?
Give a very brief answer. 0.83. What is the difference between the highest and the lowest Imports(as % of merchandise exports) of Finland?
Ensure brevity in your answer.  1.09. What is the difference between the highest and the lowest Imports(as % of merchandise exports) in Mexico?
Ensure brevity in your answer.  0.47. What is the difference between the highest and the lowest Imports(as % of merchandise exports) of Peru?
Your response must be concise. 0.22. 